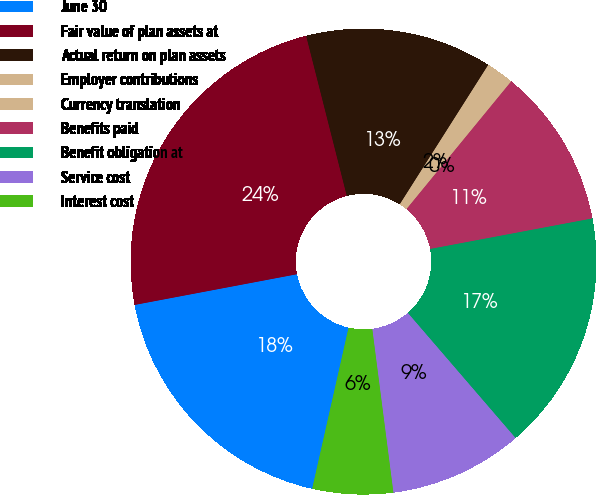Convert chart. <chart><loc_0><loc_0><loc_500><loc_500><pie_chart><fcel>June 30<fcel>Fair value of plan assets at<fcel>Actual return on plan assets<fcel>Employer contributions<fcel>Currency translation<fcel>Benefits paid<fcel>Benefit obligation at<fcel>Service cost<fcel>Interest cost<nl><fcel>18.49%<fcel>24.02%<fcel>12.96%<fcel>1.89%<fcel>0.04%<fcel>11.11%<fcel>16.65%<fcel>9.27%<fcel>5.58%<nl></chart> 